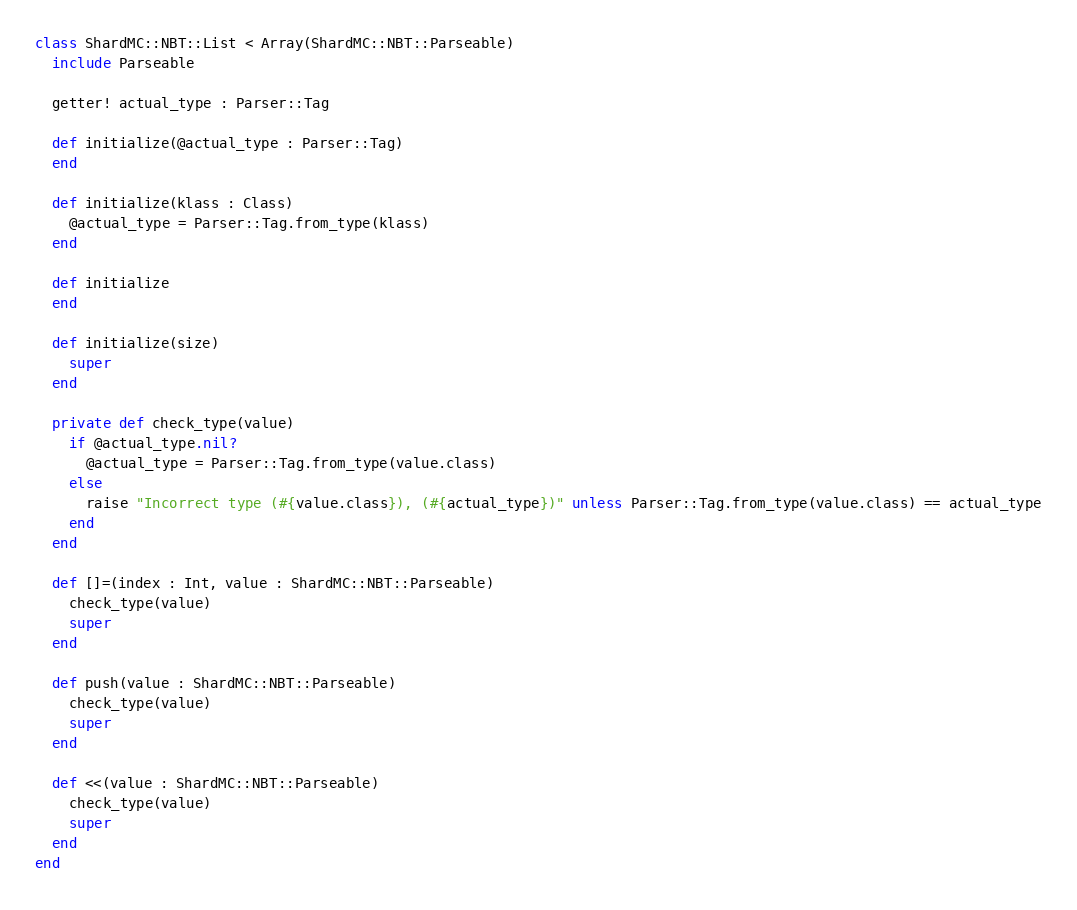<code> <loc_0><loc_0><loc_500><loc_500><_Crystal_>class ShardMC::NBT::List < Array(ShardMC::NBT::Parseable)
  include Parseable

  getter! actual_type : Parser::Tag

  def initialize(@actual_type : Parser::Tag)
  end

  def initialize(klass : Class)
    @actual_type = Parser::Tag.from_type(klass)
  end

  def initialize
  end

  def initialize(size)
    super
  end

  private def check_type(value)
    if @actual_type.nil?
      @actual_type = Parser::Tag.from_type(value.class)
    else
      raise "Incorrect type (#{value.class}), (#{actual_type})" unless Parser::Tag.from_type(value.class) == actual_type
    end
  end

  def []=(index : Int, value : ShardMC::NBT::Parseable)
    check_type(value)
    super
  end

  def push(value : ShardMC::NBT::Parseable)
    check_type(value)
    super
  end

  def <<(value : ShardMC::NBT::Parseable)
    check_type(value)
    super
  end
end
</code> 